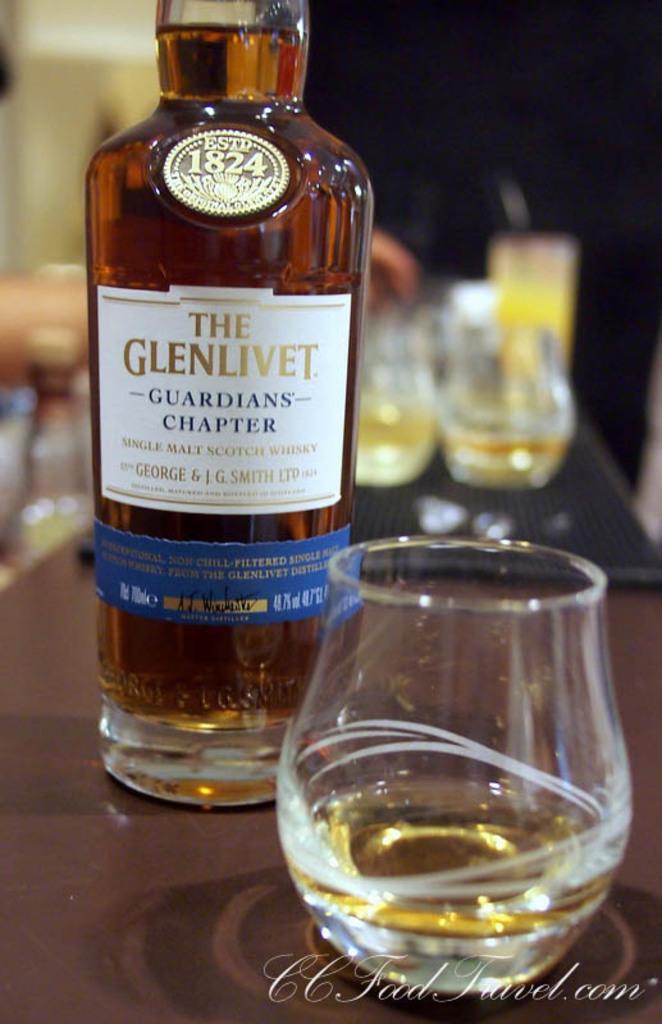What is the brand name on the bottle?
Your answer should be compact. The glenlivet. What year was the company established?
Provide a short and direct response. 1824. 